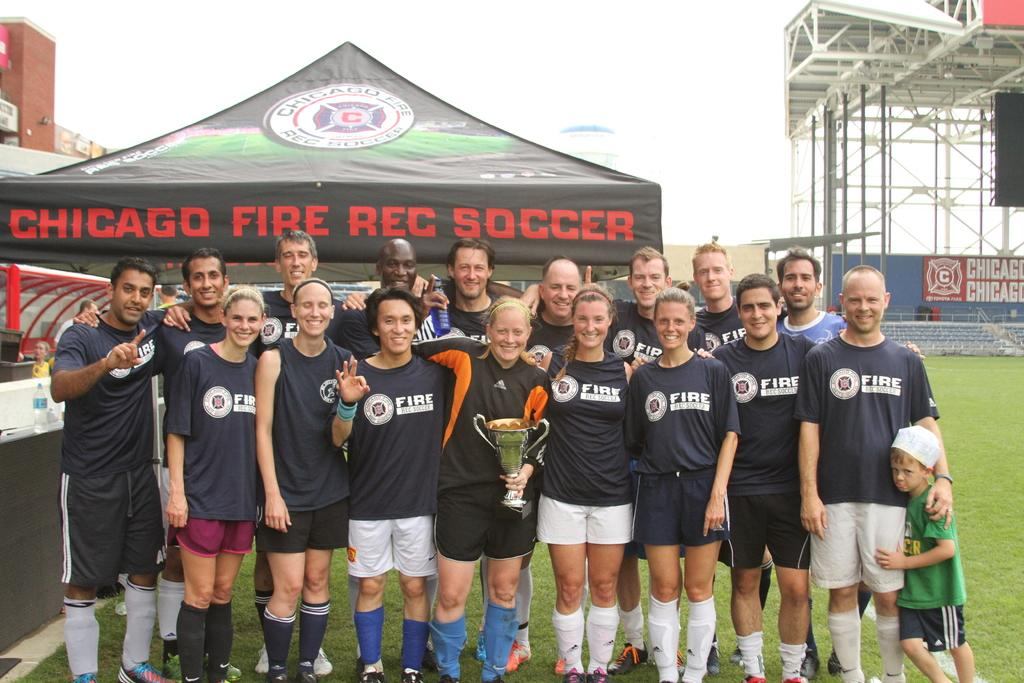<image>
Write a terse but informative summary of the picture. a fire department rec soccer team from chicago 